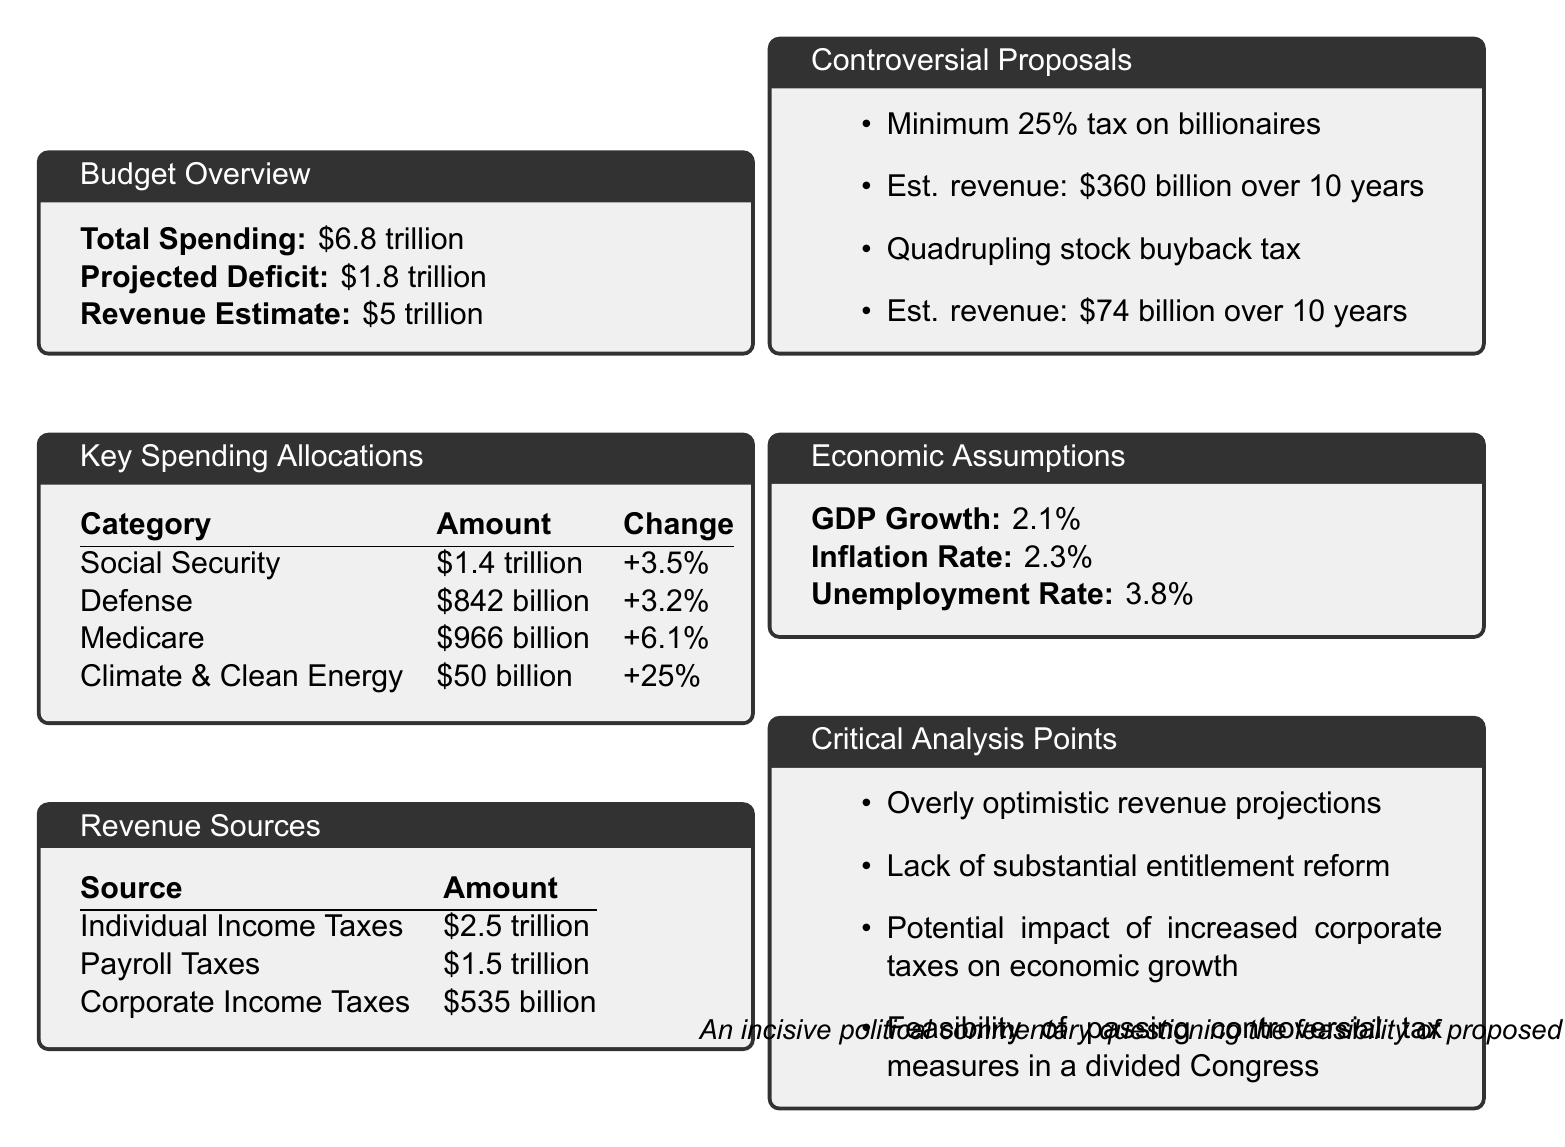What is the total spending for FY 2024? The total spending is listed in the budget overview section of the document.
Answer: $6.8 trillion What is the projected deficit? The projected deficit is indicated in the budget overview section, referring to the difference between spending and revenue.
Answer: $1.8 trillion How much is allocated for Climate & Clean Energy? The amount allocated for Climate & Clean Energy is detailed in the key spending allocations table in the document.
Answer: $50 billion What is the estimated revenue from corporate income taxes? The estimated revenue from corporate income taxes is specified in the revenue sources table.
Answer: $535 billion What is the percent change for Medicare spending? The percent change for Medicare spending is provided in the key spending allocations section.
Answer: +6.1% What is the GDP growth assumption in the economic assumptions? The GDP growth assumption is given in the economic assumptions section.
Answer: 2.1% What is the estimated revenue from the minimum 25% tax on billionaires? The estimated revenue from this tax proposal is mentioned in the controversial proposals section of the document.
Answer: $360 billion over 10 years What critical analysis point addresses revenue projections? The critical analysis points section highlights concerns regarding revenue estimates.
Answer: Overly optimistic revenue projections How much will be spent on Defense? The expenditure for Defense is cited in the key spending allocations.
Answer: $842 billion What is the unemployment rate assumption? The unemployment rate assumption is noted in the economic assumptions section of the budget.
Answer: 3.8% 